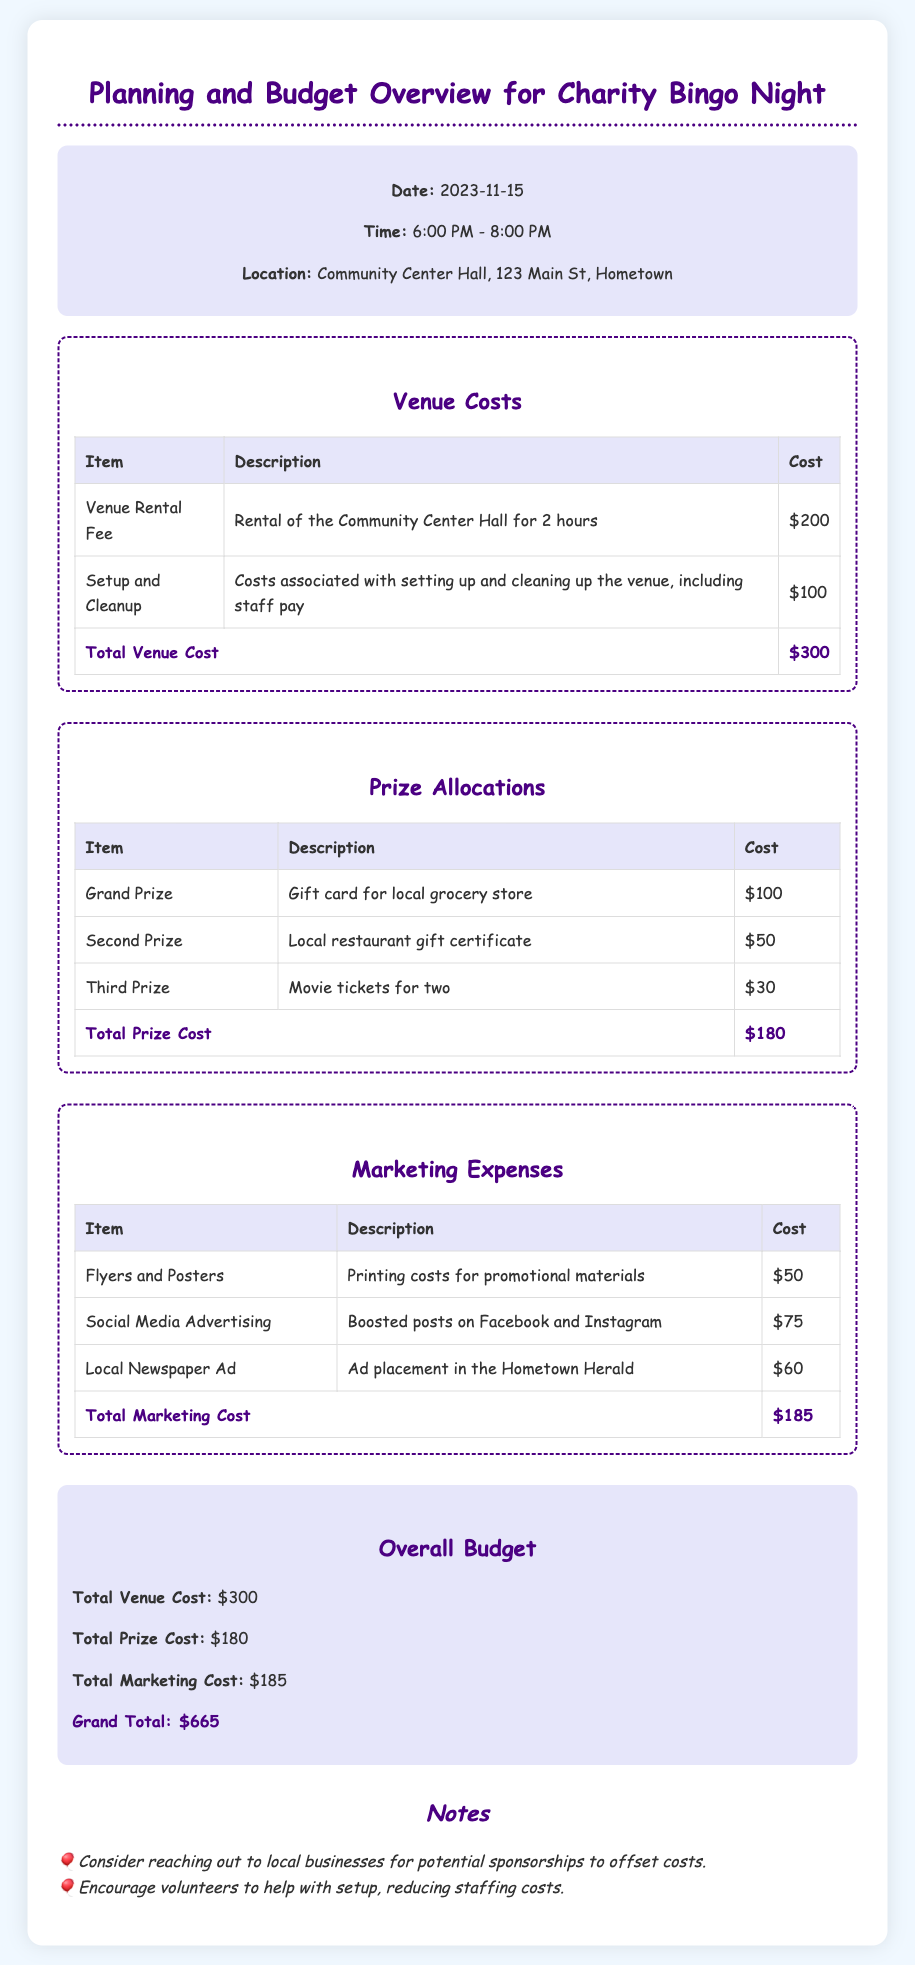what is the date of the charity bingo night? The date is specified in the event details section of the document.
Answer: 2023-11-15 what is the total cost for the venue? The total venue cost is calculated by adding the venue rental fee and setup/cleanup costs.
Answer: $300 how much is allocated for the grand prize? The grand prize amount is listed under the prize allocations section.
Answer: $100 what is the total marketing cost? The total marketing cost is found by summing up the individual marketing expenses listed in the document.
Answer: $185 where is the charity bingo night being held? The location is stated in the event details section of the document.
Answer: Community Center Hall, 123 Main St, Hometown what are the total prize costs? The total prize cost represents the sum of all prizes listed in the document.
Answer: $180 how long is the charity bingo night scheduled to last? The duration is mentioned in the event details, indicating the starting and ending times.
Answer: 2 hours what is the grand total budget for the event? The grand total is the combined total of venue, prize, and marketing costs.
Answer: $665 which marketing expense has the highest cost? The highest marketing expense can be identified by comparing the values in the marketing expenses table.
Answer: Social Media Advertising 